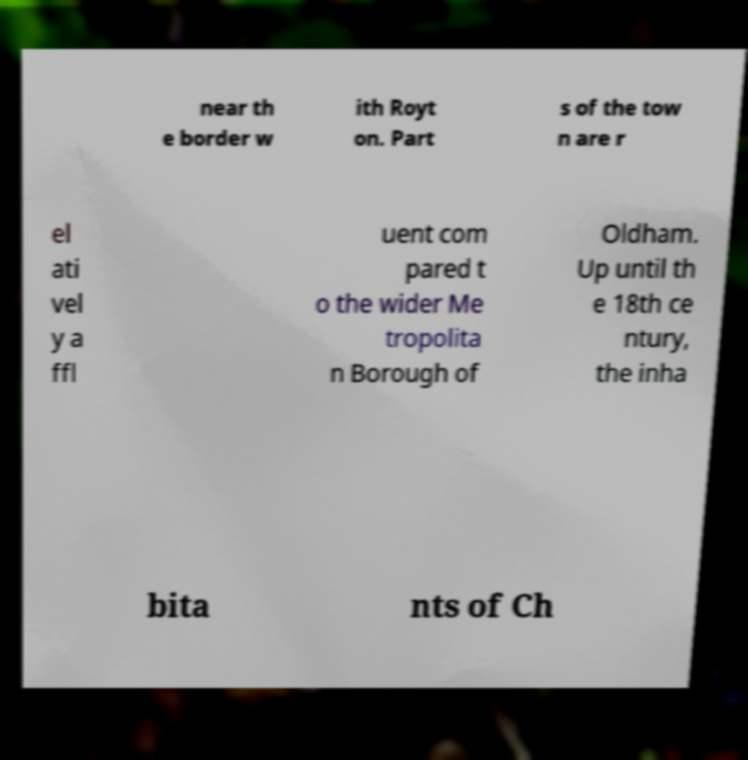Could you extract and type out the text from this image? near th e border w ith Royt on. Part s of the tow n are r el ati vel y a ffl uent com pared t o the wider Me tropolita n Borough of Oldham. Up until th e 18th ce ntury, the inha bita nts of Ch 